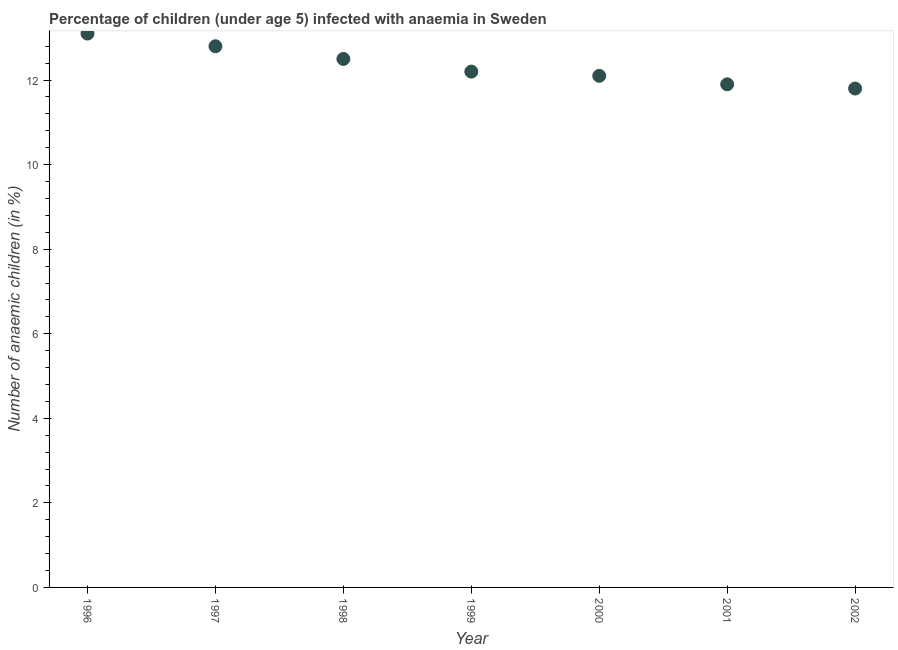Across all years, what is the maximum number of anaemic children?
Offer a very short reply. 13.1. In which year was the number of anaemic children maximum?
Keep it short and to the point. 1996. In which year was the number of anaemic children minimum?
Your response must be concise. 2002. What is the sum of the number of anaemic children?
Offer a terse response. 86.4. What is the difference between the number of anaemic children in 1996 and 1999?
Offer a terse response. 0.9. What is the average number of anaemic children per year?
Offer a very short reply. 12.34. What is the median number of anaemic children?
Provide a succinct answer. 12.2. In how many years, is the number of anaemic children greater than 11.6 %?
Offer a very short reply. 7. What is the ratio of the number of anaemic children in 1998 to that in 2001?
Provide a succinct answer. 1.05. What is the difference between the highest and the second highest number of anaemic children?
Your answer should be very brief. 0.3. Is the sum of the number of anaemic children in 2001 and 2002 greater than the maximum number of anaemic children across all years?
Give a very brief answer. Yes. What is the difference between the highest and the lowest number of anaemic children?
Offer a very short reply. 1.3. How many years are there in the graph?
Make the answer very short. 7. What is the difference between two consecutive major ticks on the Y-axis?
Keep it short and to the point. 2. Does the graph contain any zero values?
Ensure brevity in your answer.  No. Does the graph contain grids?
Offer a terse response. No. What is the title of the graph?
Keep it short and to the point. Percentage of children (under age 5) infected with anaemia in Sweden. What is the label or title of the X-axis?
Your answer should be very brief. Year. What is the label or title of the Y-axis?
Your answer should be compact. Number of anaemic children (in %). What is the Number of anaemic children (in %) in 1996?
Provide a short and direct response. 13.1. What is the Number of anaemic children (in %) in 2001?
Offer a terse response. 11.9. What is the difference between the Number of anaemic children (in %) in 1996 and 1998?
Your answer should be compact. 0.6. What is the difference between the Number of anaemic children (in %) in 1996 and 1999?
Provide a succinct answer. 0.9. What is the difference between the Number of anaemic children (in %) in 1996 and 2000?
Provide a succinct answer. 1. What is the difference between the Number of anaemic children (in %) in 1996 and 2001?
Your answer should be compact. 1.2. What is the difference between the Number of anaemic children (in %) in 1997 and 1998?
Your answer should be compact. 0.3. What is the difference between the Number of anaemic children (in %) in 1997 and 2000?
Ensure brevity in your answer.  0.7. What is the difference between the Number of anaemic children (in %) in 1997 and 2001?
Make the answer very short. 0.9. What is the difference between the Number of anaemic children (in %) in 1998 and 1999?
Provide a short and direct response. 0.3. What is the difference between the Number of anaemic children (in %) in 1998 and 2000?
Your response must be concise. 0.4. What is the difference between the Number of anaemic children (in %) in 1998 and 2001?
Ensure brevity in your answer.  0.6. What is the difference between the Number of anaemic children (in %) in 1998 and 2002?
Provide a short and direct response. 0.7. What is the difference between the Number of anaemic children (in %) in 1999 and 2002?
Keep it short and to the point. 0.4. What is the difference between the Number of anaemic children (in %) in 2000 and 2001?
Offer a very short reply. 0.2. What is the difference between the Number of anaemic children (in %) in 2001 and 2002?
Your answer should be very brief. 0.1. What is the ratio of the Number of anaemic children (in %) in 1996 to that in 1997?
Ensure brevity in your answer.  1.02. What is the ratio of the Number of anaemic children (in %) in 1996 to that in 1998?
Make the answer very short. 1.05. What is the ratio of the Number of anaemic children (in %) in 1996 to that in 1999?
Provide a short and direct response. 1.07. What is the ratio of the Number of anaemic children (in %) in 1996 to that in 2000?
Provide a short and direct response. 1.08. What is the ratio of the Number of anaemic children (in %) in 1996 to that in 2001?
Give a very brief answer. 1.1. What is the ratio of the Number of anaemic children (in %) in 1996 to that in 2002?
Offer a very short reply. 1.11. What is the ratio of the Number of anaemic children (in %) in 1997 to that in 1999?
Your answer should be compact. 1.05. What is the ratio of the Number of anaemic children (in %) in 1997 to that in 2000?
Provide a short and direct response. 1.06. What is the ratio of the Number of anaemic children (in %) in 1997 to that in 2001?
Ensure brevity in your answer.  1.08. What is the ratio of the Number of anaemic children (in %) in 1997 to that in 2002?
Provide a succinct answer. 1.08. What is the ratio of the Number of anaemic children (in %) in 1998 to that in 2000?
Offer a terse response. 1.03. What is the ratio of the Number of anaemic children (in %) in 1998 to that in 2001?
Provide a succinct answer. 1.05. What is the ratio of the Number of anaemic children (in %) in 1998 to that in 2002?
Your response must be concise. 1.06. What is the ratio of the Number of anaemic children (in %) in 1999 to that in 2001?
Provide a short and direct response. 1.02. What is the ratio of the Number of anaemic children (in %) in 1999 to that in 2002?
Offer a terse response. 1.03. What is the ratio of the Number of anaemic children (in %) in 2000 to that in 2001?
Your answer should be very brief. 1.02. What is the ratio of the Number of anaemic children (in %) in 2001 to that in 2002?
Provide a short and direct response. 1.01. 